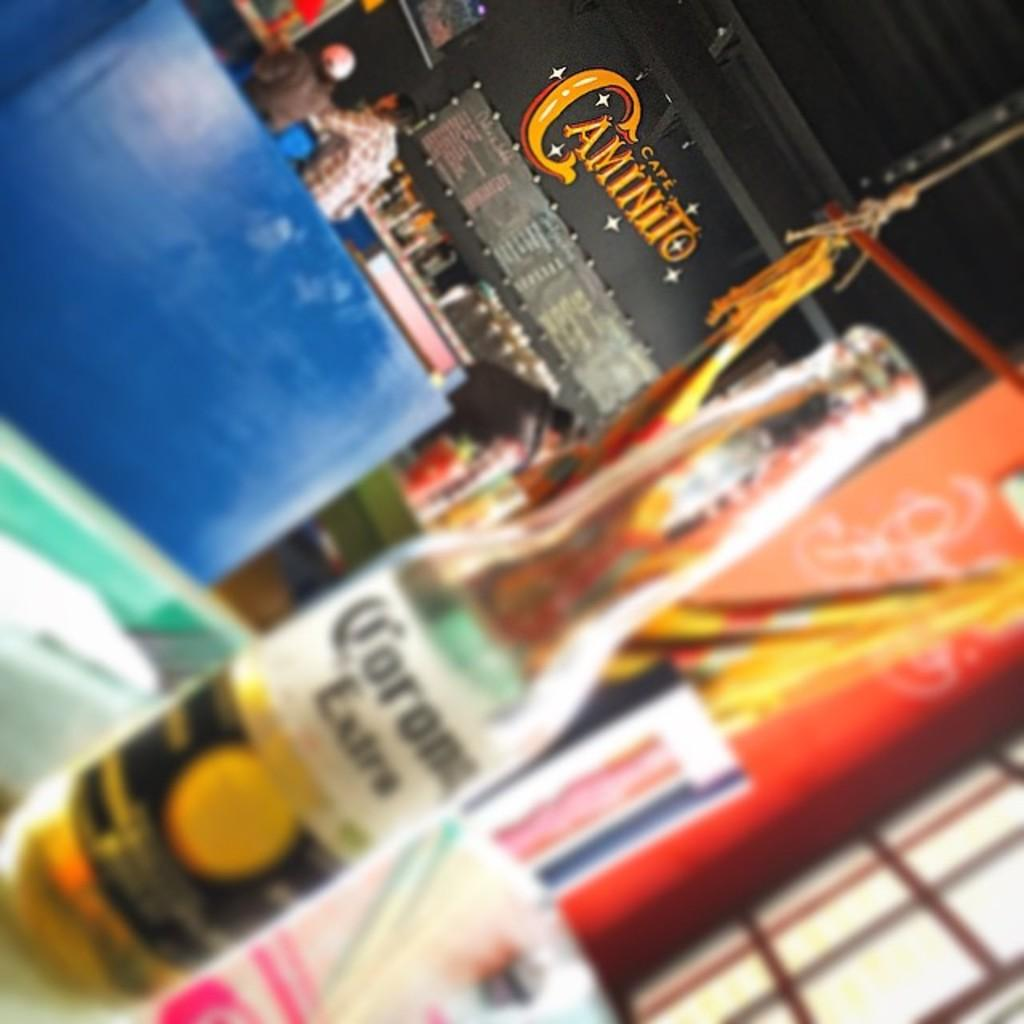What is on the table in the image? There is a wine bottle on the table in the image. Who or what can be seen in the image? There are people in the image. What type of furniture is present in the image? There are chairs in the image. What else can be seen on the table besides the wine bottle? There are bottles on the table in the image. What other objects are visible in the image? There are boards and other objects in the image. What type of nut is being traded in the image? There is no indication of any trade or nut in the image. Can you see a bat flying in the image? There is no bat visible in the image. 